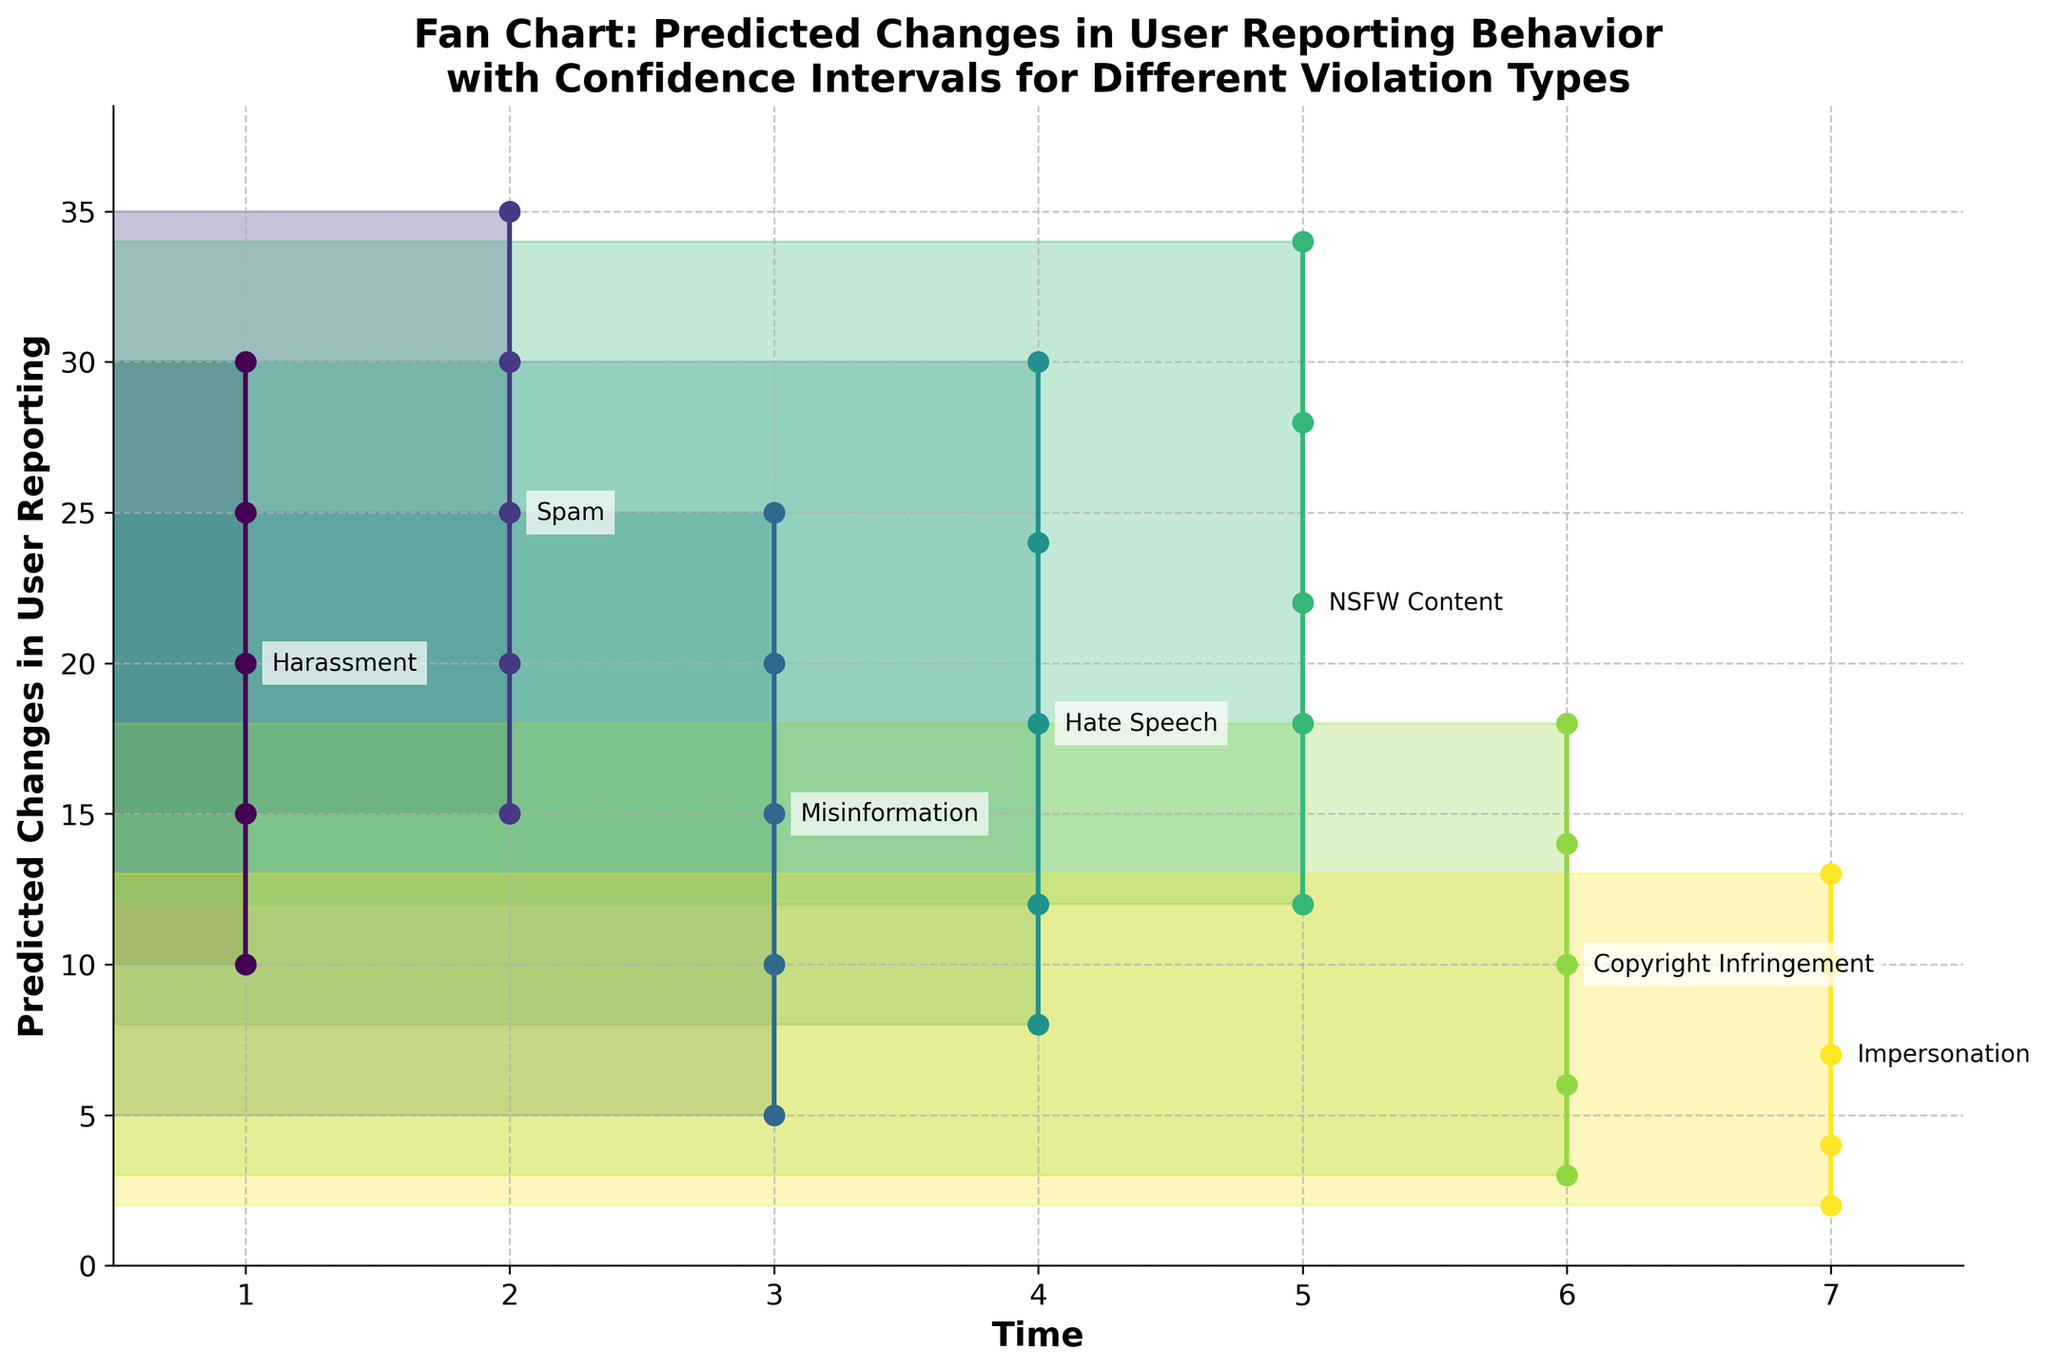What's the title of the fan chart? The title is located at the top of the figure and provides an overview of what the chart represents. Here it reads: "Fan Chart: Predicted Changes in User Reporting Behavior with Confidence Intervals for Different Violation Types"
Answer: Fan Chart: Predicted Changes in User Reporting Behavior with Confidence Intervals for Different Violation Types What does the y-axis represent? The y-axis labels and title indicate that it represents the "Predicted Changes in User Reporting." This is the variable of interest that shows different levels of reporting behavior.
Answer: Predicted Changes in User Reporting Which violation type has the highest median value in predicted changes? The median values are indicated by labeled points along the middle line of each fan. By comparing these, we see "Spam" has the highest median value of 25.
Answer: Spam What is the range of the lower and upper 75% confidence intervals for NSFW Content? For NSFW Content, the lower 75% CI is at 18, and the upper 75% CI is at 28.
Answer: 18 to 28 How does the median predicted change in reporting for Harassment compare to Hate Speech? Compare the median values of Harassment and Hate Speech. Harassment has a median value of 20, while Hate Speech has a median value of 18, so Harassment has a higher median.
Answer: Harassment has a higher median Which violation type has the narrowest confidence interval range in the 95% CI? Evaluate the 95% CI ranges for each violation type by subtracting the lower value from the upper value. Impersonation has the narrowest range (13 - 2 = 11).
Answer: Impersonation What's the overall trend in median predicted changes in user reporting behavior from time 1 to 7? Observing the overall trend in median values from Time 1 to Time 7, generally, the median values are fluctuating without a consistent upward or downward trend.
Answer: Fluctuating trend What is the smallest value in the upper 95% CI across all violation types? Reviewing the upper 95% CI values for all violation types, the smallest value is 13 for Impersonation.
Answer: 13 Which violation type shows the lowest variability in predicted user reporting behavior? Assess the variability by looking at the range across the confidence intervals. Impersonation shows the lowest variability as the ranges are generally narrowest.
Answer: Impersonation If we consider both the median levels and confidence intervals, which violation type exhibits the most uncertain predicted changes in user reporting behavior? Consider both the median levels and the width of confidence intervals to determine uncertainty. Hate Speech shows considerable uncertainty with wider confidence intervals.
Answer: Hate Speech 